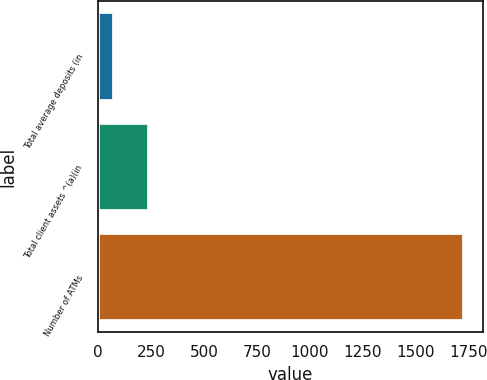Convert chart to OTSL. <chart><loc_0><loc_0><loc_500><loc_500><bar_chart><fcel>Total average deposits (in<fcel>Total client assets ^(a)(in<fcel>Number of ATMs<nl><fcel>75.1<fcel>240.59<fcel>1730<nl></chart> 